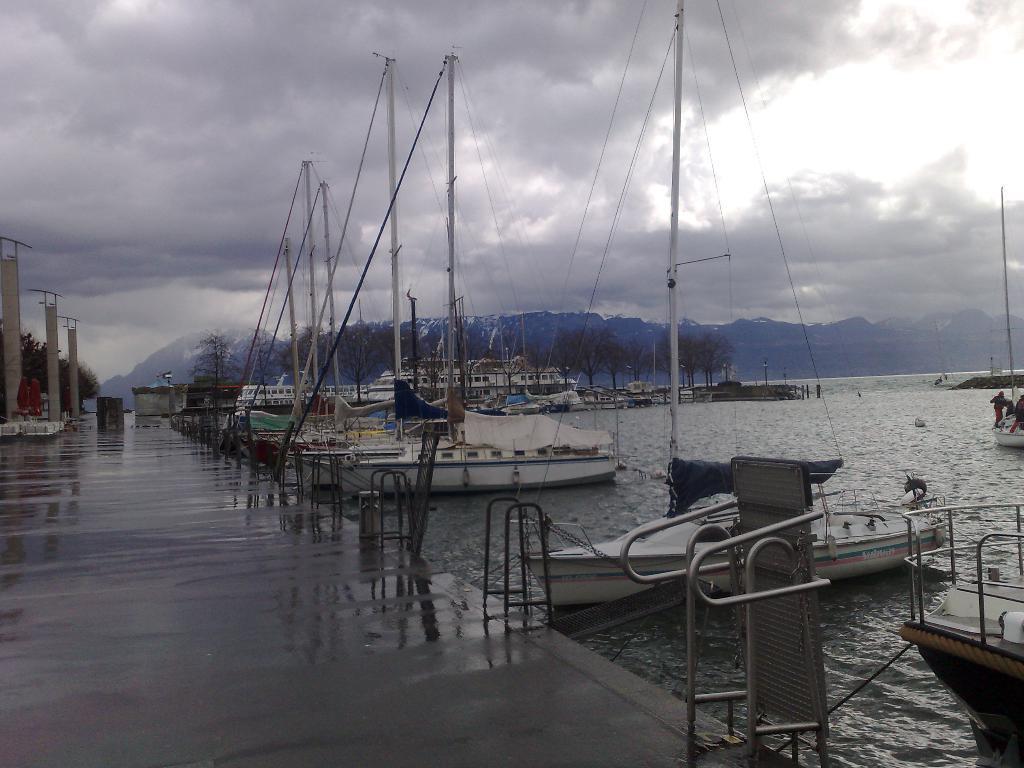In one or two sentences, can you explain what this image depicts? In this image there is water and we can see ships on the water. On the left there is a board bridge. In the background there are trees, hills and sky. We can see railings and there are poles. 